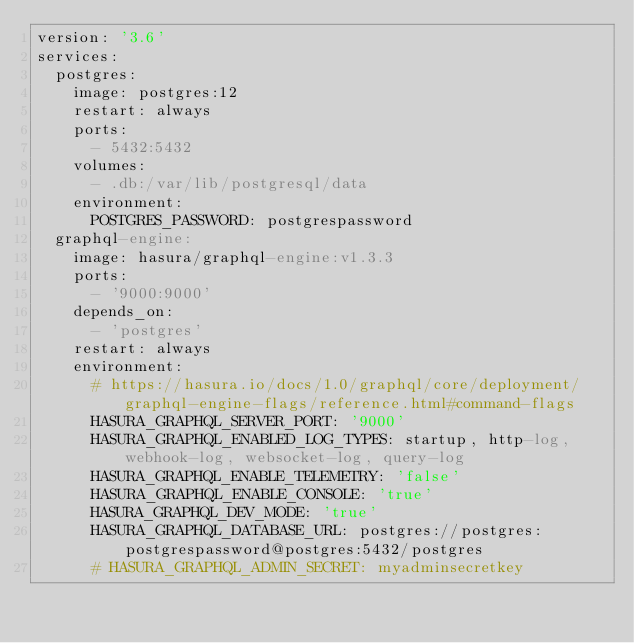<code> <loc_0><loc_0><loc_500><loc_500><_YAML_>version: '3.6'
services:
  postgres:
    image: postgres:12
    restart: always
    ports:
      - 5432:5432
    volumes:
      - .db:/var/lib/postgresql/data
    environment:
      POSTGRES_PASSWORD: postgrespassword
  graphql-engine:
    image: hasura/graphql-engine:v1.3.3
    ports:
      - '9000:9000'
    depends_on:
      - 'postgres'
    restart: always
    environment:
      # https://hasura.io/docs/1.0/graphql/core/deployment/graphql-engine-flags/reference.html#command-flags
      HASURA_GRAPHQL_SERVER_PORT: '9000'
      HASURA_GRAPHQL_ENABLED_LOG_TYPES: startup, http-log, webhook-log, websocket-log, query-log
      HASURA_GRAPHQL_ENABLE_TELEMETRY: 'false'
      HASURA_GRAPHQL_ENABLE_CONSOLE: 'true'
      HASURA_GRAPHQL_DEV_MODE: 'true'
      HASURA_GRAPHQL_DATABASE_URL: postgres://postgres:postgrespassword@postgres:5432/postgres
      # HASURA_GRAPHQL_ADMIN_SECRET: myadminsecretkey
</code> 